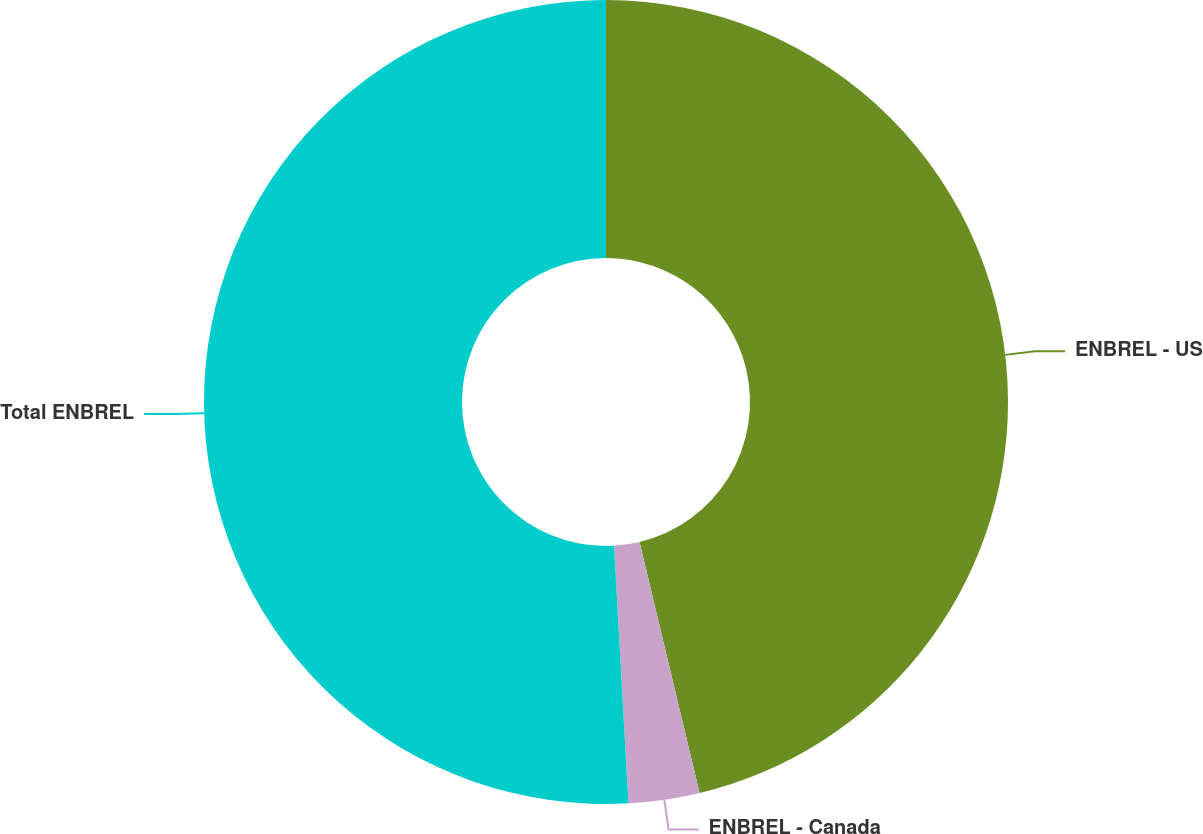Convert chart. <chart><loc_0><loc_0><loc_500><loc_500><pie_chart><fcel>ENBREL - US<fcel>ENBREL - Canada<fcel>Total ENBREL<nl><fcel>46.26%<fcel>2.85%<fcel>50.89%<nl></chart> 